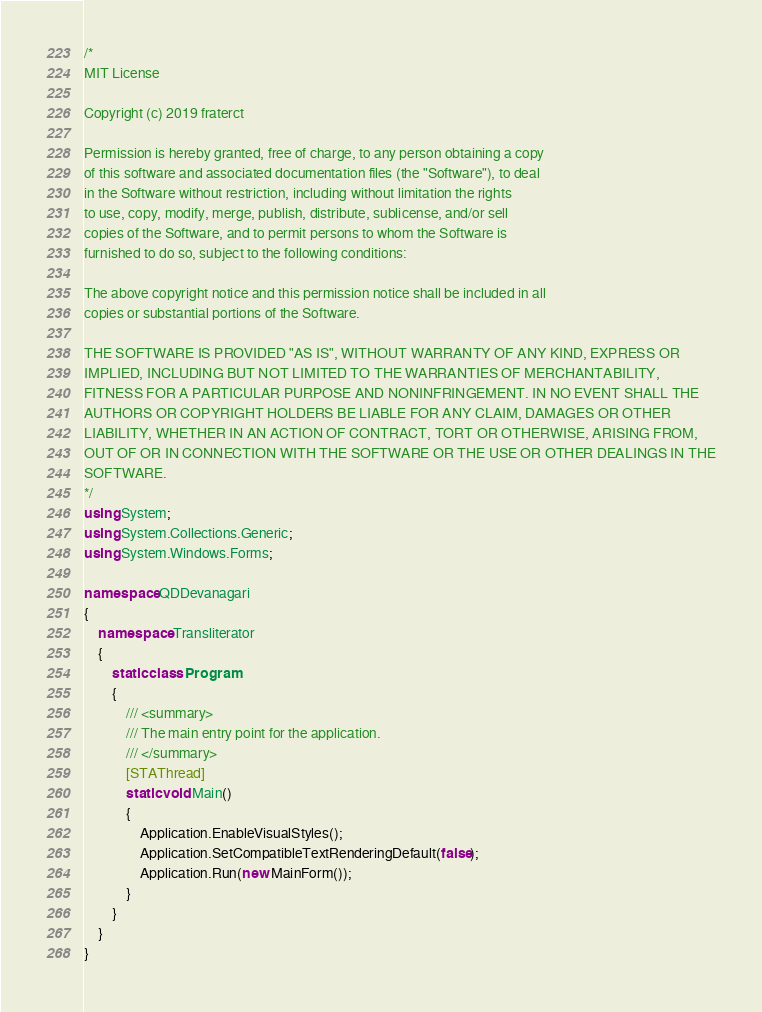<code> <loc_0><loc_0><loc_500><loc_500><_C#_>/*
MIT License

Copyright (c) 2019 fraterct

Permission is hereby granted, free of charge, to any person obtaining a copy
of this software and associated documentation files (the "Software"), to deal
in the Software without restriction, including without limitation the rights
to use, copy, modify, merge, publish, distribute, sublicense, and/or sell
copies of the Software, and to permit persons to whom the Software is
furnished to do so, subject to the following conditions:

The above copyright notice and this permission notice shall be included in all
copies or substantial portions of the Software.

THE SOFTWARE IS PROVIDED "AS IS", WITHOUT WARRANTY OF ANY KIND, EXPRESS OR
IMPLIED, INCLUDING BUT NOT LIMITED TO THE WARRANTIES OF MERCHANTABILITY,
FITNESS FOR A PARTICULAR PURPOSE AND NONINFRINGEMENT. IN NO EVENT SHALL THE
AUTHORS OR COPYRIGHT HOLDERS BE LIABLE FOR ANY CLAIM, DAMAGES OR OTHER
LIABILITY, WHETHER IN AN ACTION OF CONTRACT, TORT OR OTHERWISE, ARISING FROM,
OUT OF OR IN CONNECTION WITH THE SOFTWARE OR THE USE OR OTHER DEALINGS IN THE
SOFTWARE.
*/
using System;
using System.Collections.Generic;
using System.Windows.Forms;

namespace QDDevanagari
{
    namespace Transliterator
    {
        static class Program
        {
            /// <summary>
            /// The main entry point for the application.
            /// </summary>
            [STAThread]
            static void Main()
            {
                Application.EnableVisualStyles();
                Application.SetCompatibleTextRenderingDefault(false);
                Application.Run(new MainForm());
            }
        }
    }
}</code> 